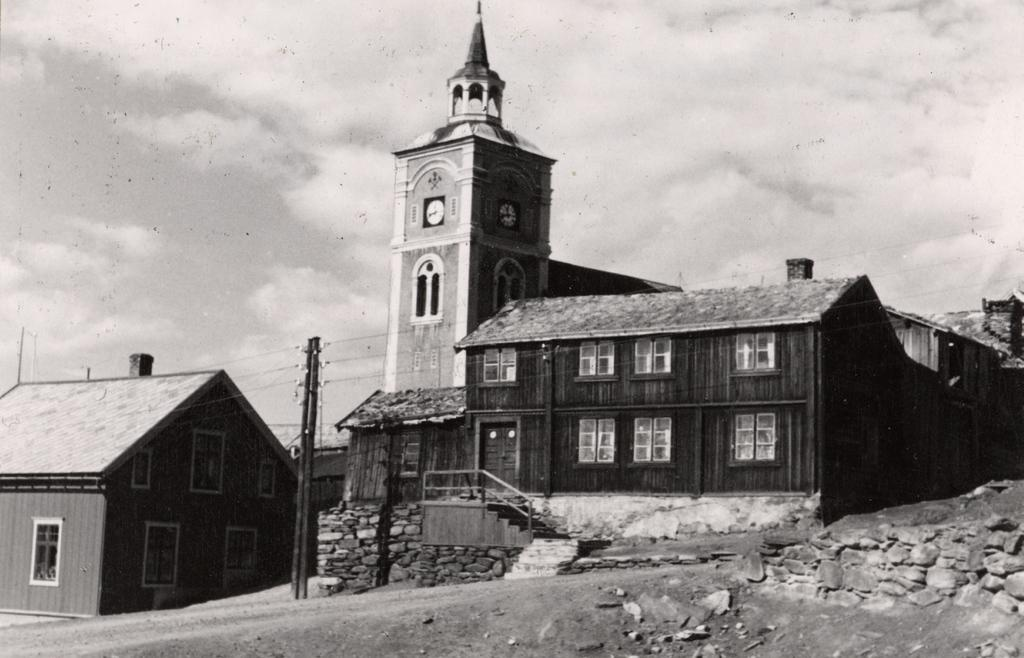What is the color scheme of the image? The image is black and white. What type of structures can be seen in the image? There are houses in the image. What other objects are present in the image? There are poles and clocks in the image. What can be seen in the background of the image? The sky with clouds is visible in the background of the image. Where are the boys playing with lettuce in the image? There are no boys or lettuce present in the image. What type of authority figure can be seen in the image? There is no authority figure present in the image. 